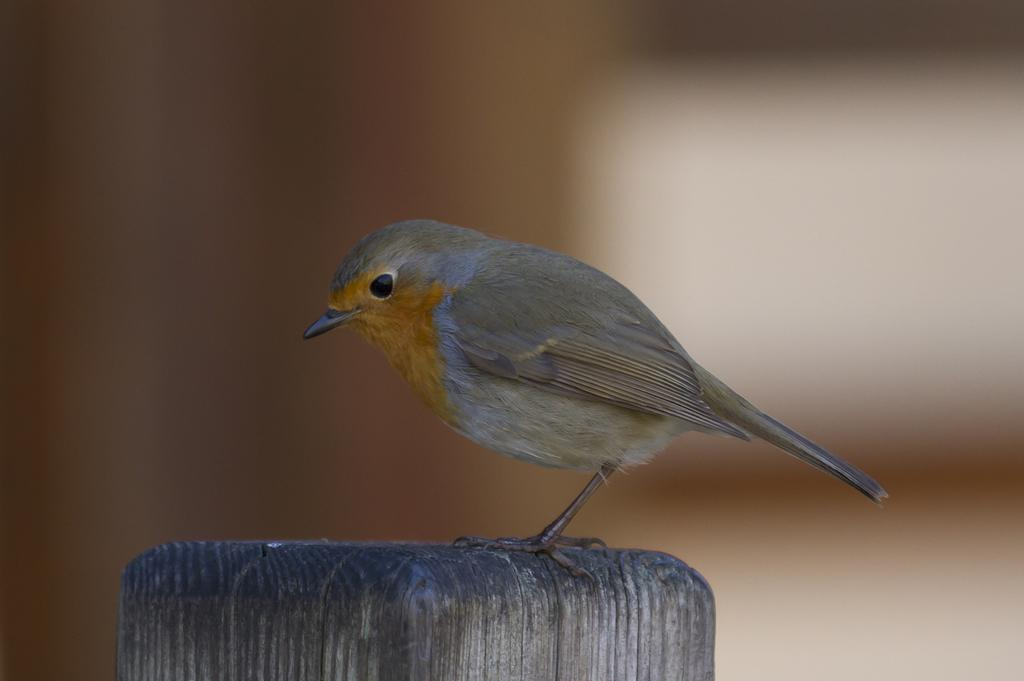What type of animal is in the image? There is a bird in the image. Where is the bird located in the image? The bird is on a path. Can you see the bird swimming in the image? No, the bird is not swimming in the image; it is on a path. 